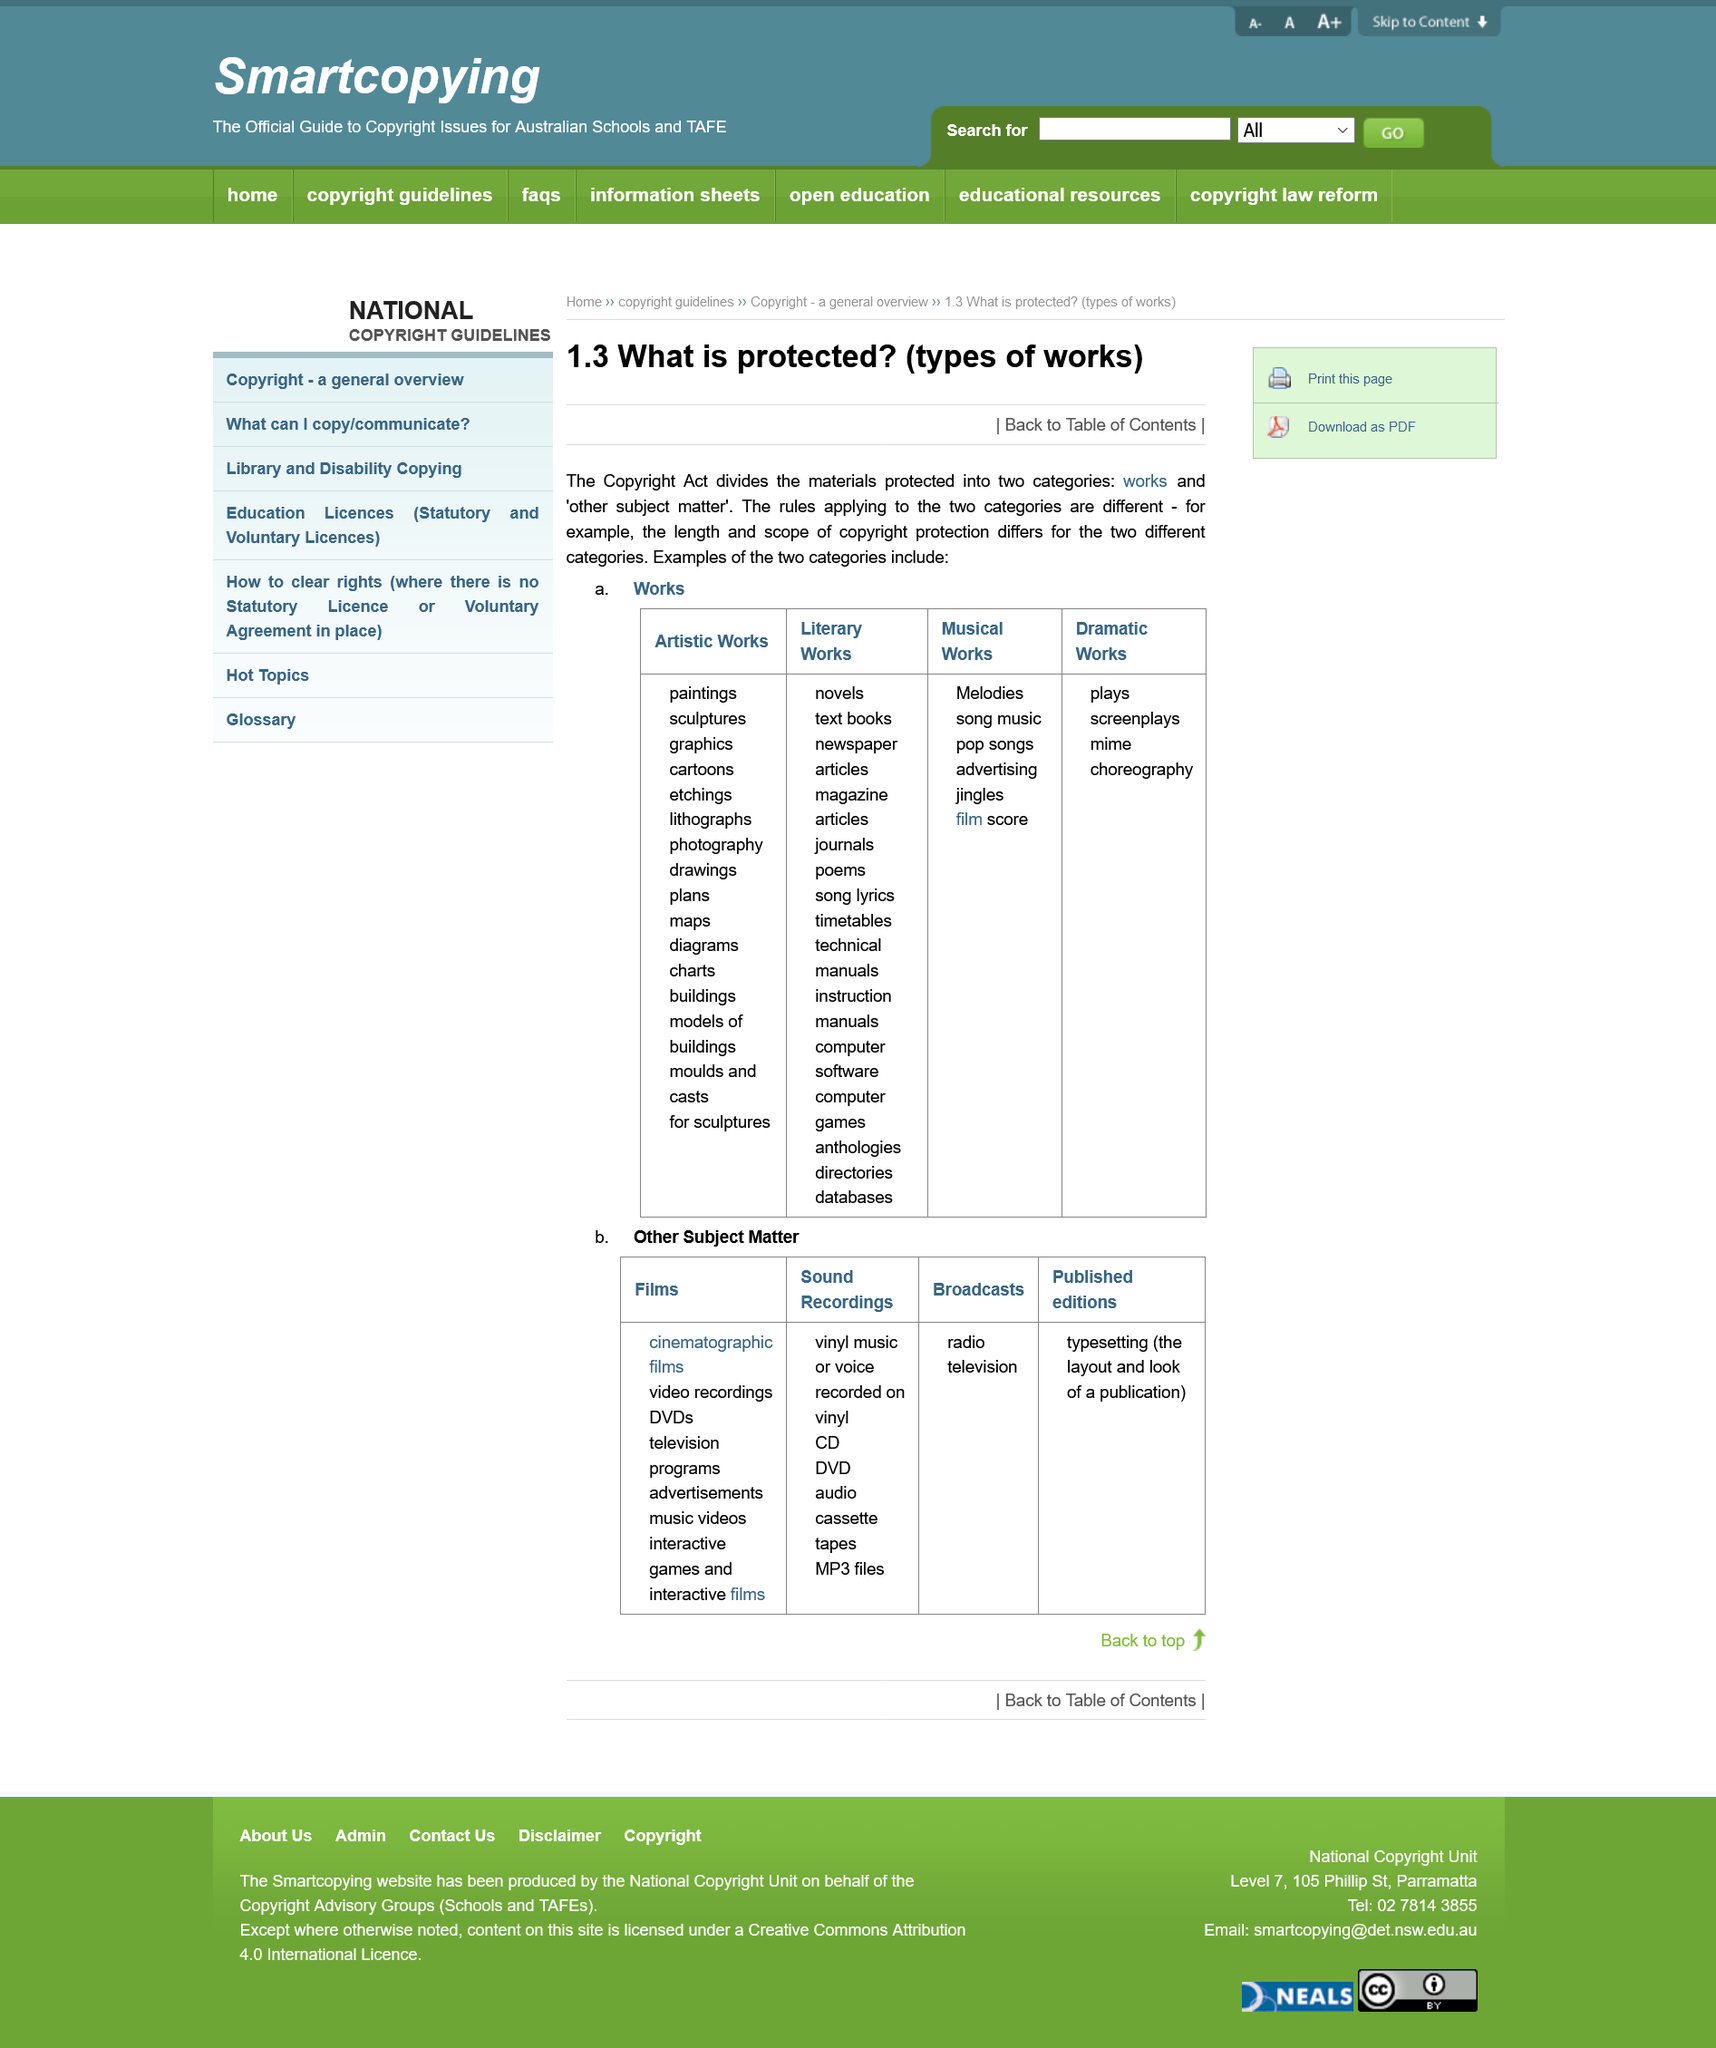Highlight a few significant elements in this photo. Under the Copyright Act, there are two categories of works that are considered 'protected' and are afforded special legal protections: 'artistic works' and 'literary works'. Under the Copyright Act, protected materials are categorized into two categories: 'works' and 'other subject matter.' The Copyright Act covers two types of musical works: melodies and pop songs. 